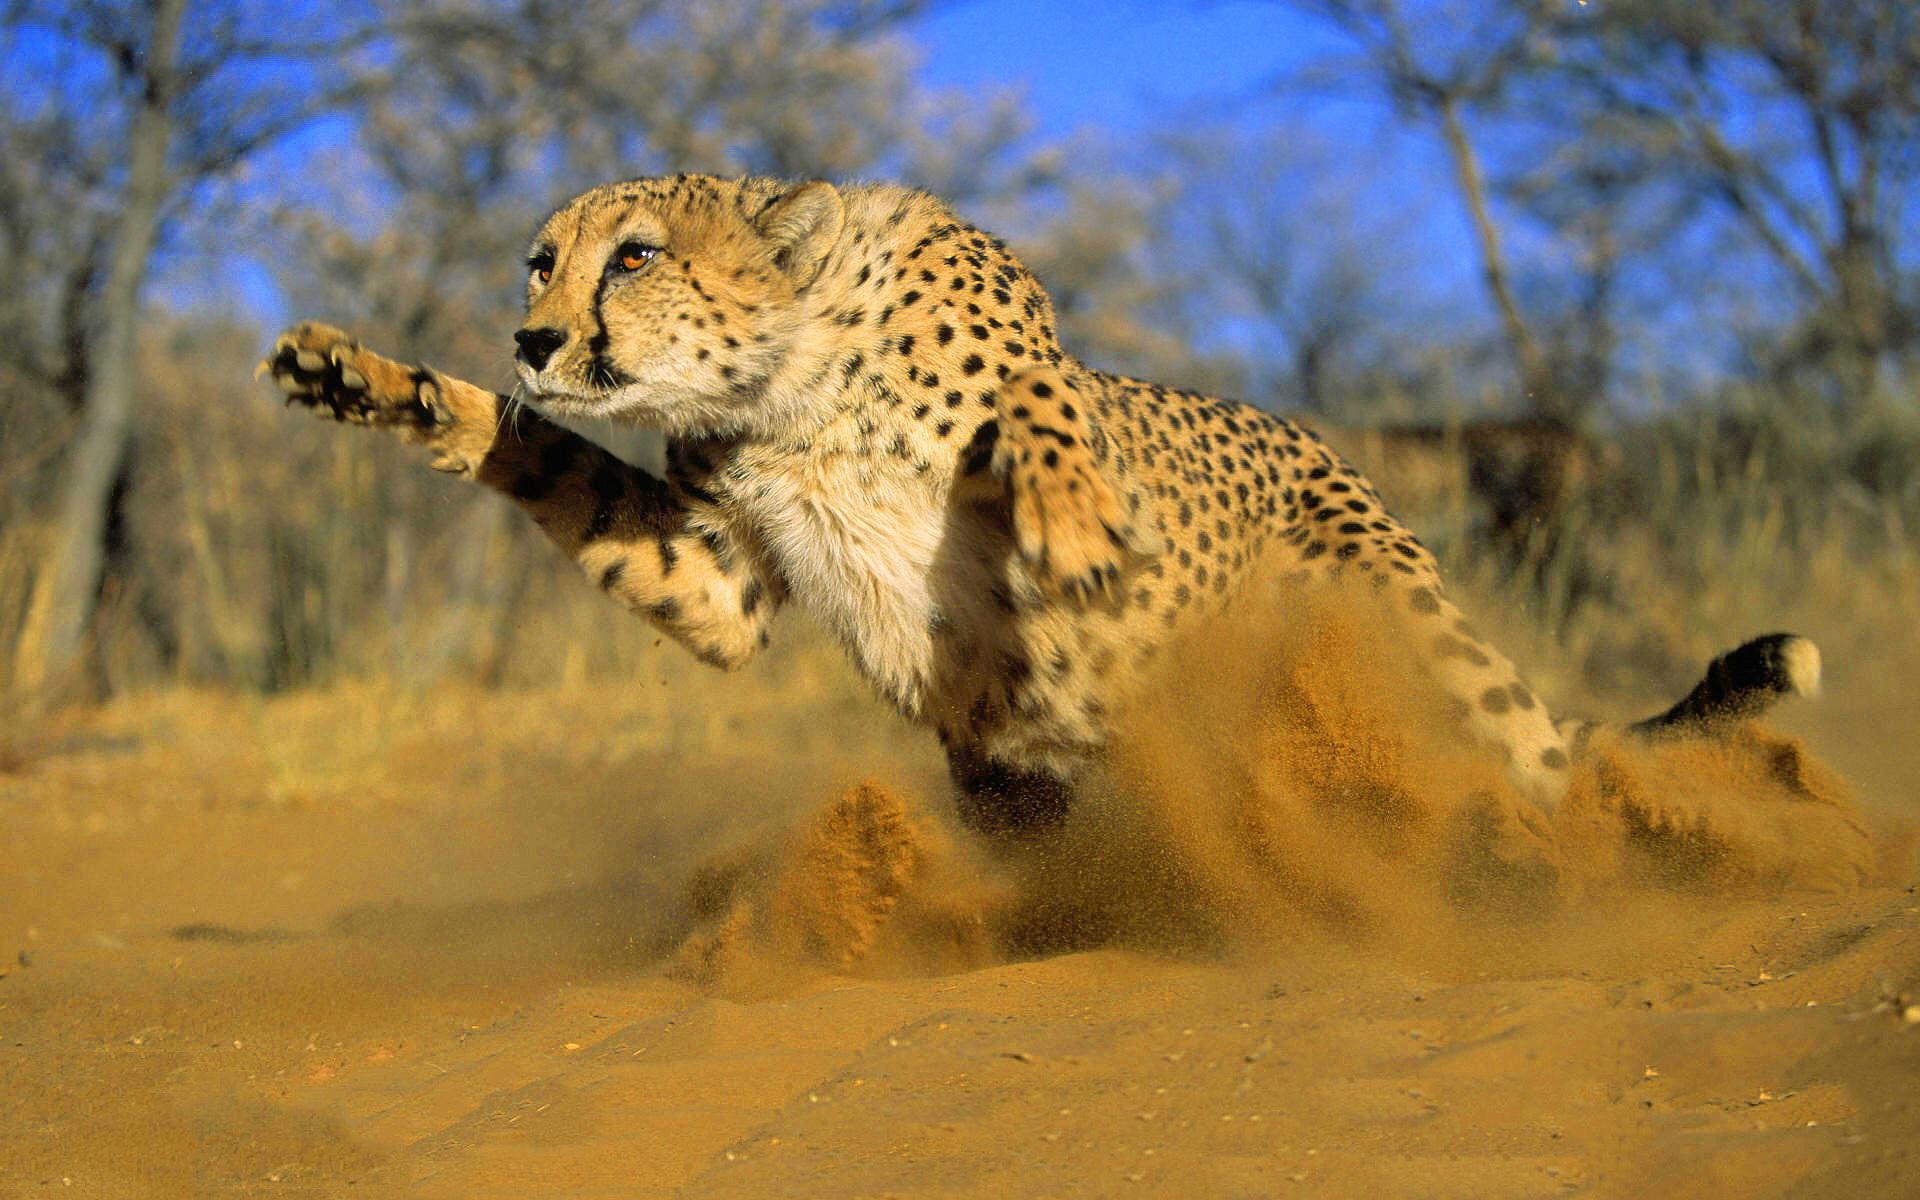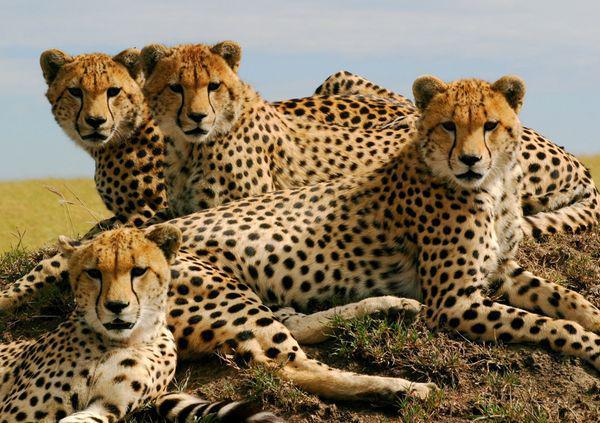The first image is the image on the left, the second image is the image on the right. Examine the images to the left and right. Is the description "An image depicts just one cheetah, which is in a leaping pose." accurate? Answer yes or no. Yes. 